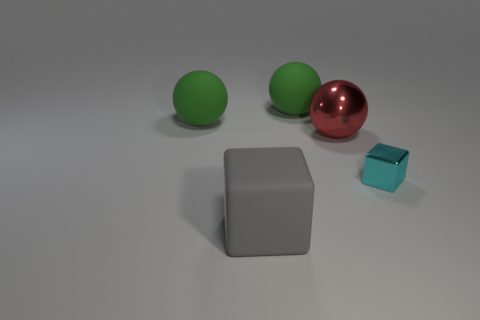Subtract all cyan spheres. Subtract all brown cubes. How many spheres are left? 3 Add 1 small blocks. How many objects exist? 6 Subtract all blocks. How many objects are left? 3 Subtract 0 red blocks. How many objects are left? 5 Subtract all big green matte cylinders. Subtract all large red shiny balls. How many objects are left? 4 Add 1 large blocks. How many large blocks are left? 2 Add 5 tiny purple shiny objects. How many tiny purple shiny objects exist? 5 